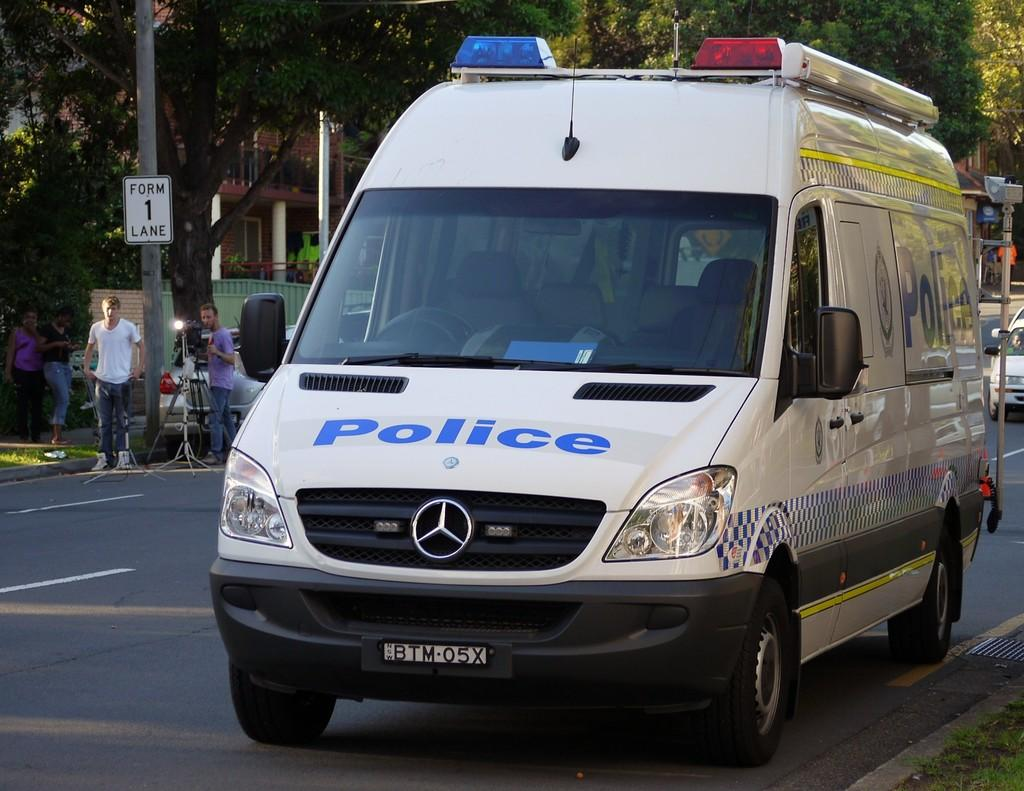<image>
Write a terse but informative summary of the picture. A white van has the word police on the front and red and blue lights on the top. 